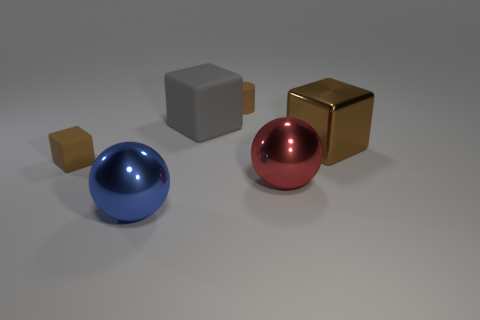What is the color of the block that is the same size as the brown cylinder?
Keep it short and to the point. Brown. Are there any large things of the same color as the matte cylinder?
Keep it short and to the point. Yes. What number of things are matte objects to the right of the gray object or small blue shiny blocks?
Give a very brief answer. 1. What number of other things are the same size as the red metal thing?
Make the answer very short. 3. There is a sphere that is left of the small thing to the right of the brown thing that is in front of the big shiny block; what is its material?
Ensure brevity in your answer.  Metal. What number of balls are either blue objects or brown objects?
Provide a short and direct response. 1. Is there anything else that is the same shape as the big gray matte object?
Offer a very short reply. Yes. Is the number of blocks that are behind the large gray block greater than the number of brown blocks that are in front of the tiny matte cube?
Offer a very short reply. No. There is a large block that is left of the tiny brown rubber cylinder; what number of brown cylinders are right of it?
Keep it short and to the point. 1. What number of objects are small matte objects or brown metal objects?
Your response must be concise. 3. 